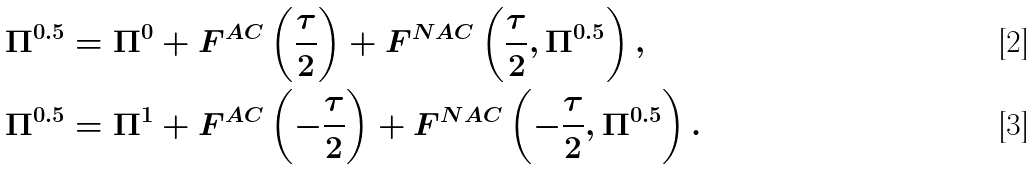Convert formula to latex. <formula><loc_0><loc_0><loc_500><loc_500>\Pi ^ { 0 . 5 } & = \Pi ^ { 0 } + F ^ { A C } \left ( \frac { \tau } { 2 } \right ) + F ^ { N A C } \left ( \frac { \tau } { 2 } , \Pi ^ { 0 . 5 } \right ) , \\ \Pi ^ { 0 . 5 } & = \Pi ^ { 1 } + F ^ { A C } \left ( - \frac { \tau } { 2 } \right ) + F ^ { N A C } \left ( - \frac { \tau } { 2 } , \Pi ^ { 0 . 5 } \right ) .</formula> 